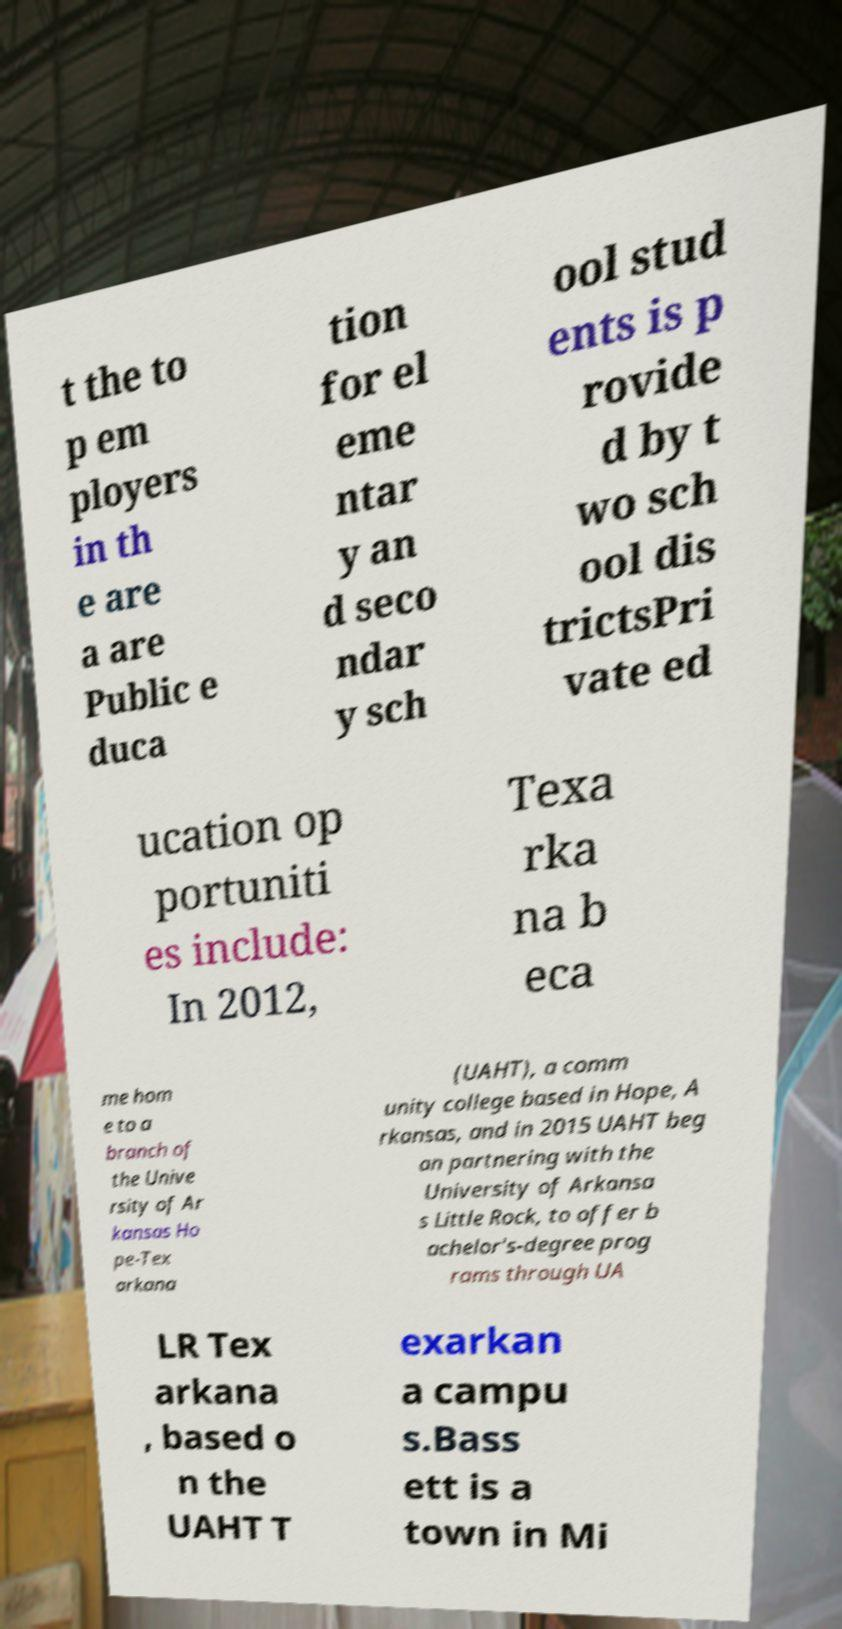Could you extract and type out the text from this image? t the to p em ployers in th e are a are Public e duca tion for el eme ntar y an d seco ndar y sch ool stud ents is p rovide d by t wo sch ool dis trictsPri vate ed ucation op portuniti es include: In 2012, Texa rka na b eca me hom e to a branch of the Unive rsity of Ar kansas Ho pe-Tex arkana (UAHT), a comm unity college based in Hope, A rkansas, and in 2015 UAHT beg an partnering with the University of Arkansa s Little Rock, to offer b achelor's-degree prog rams through UA LR Tex arkana , based o n the UAHT T exarkan a campu s.Bass ett is a town in Mi 